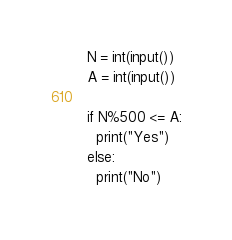Convert code to text. <code><loc_0><loc_0><loc_500><loc_500><_Python_>N = int(input())
A = int(input())

if N%500 <= A:
  print("Yes")
else:
  print("No")</code> 